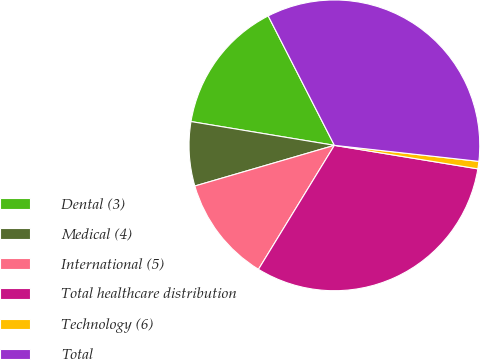Convert chart. <chart><loc_0><loc_0><loc_500><loc_500><pie_chart><fcel>Dental (3)<fcel>Medical (4)<fcel>International (5)<fcel>Total healthcare distribution<fcel>Technology (6)<fcel>Total<nl><fcel>14.86%<fcel>7.13%<fcel>11.74%<fcel>31.16%<fcel>0.83%<fcel>34.28%<nl></chart> 